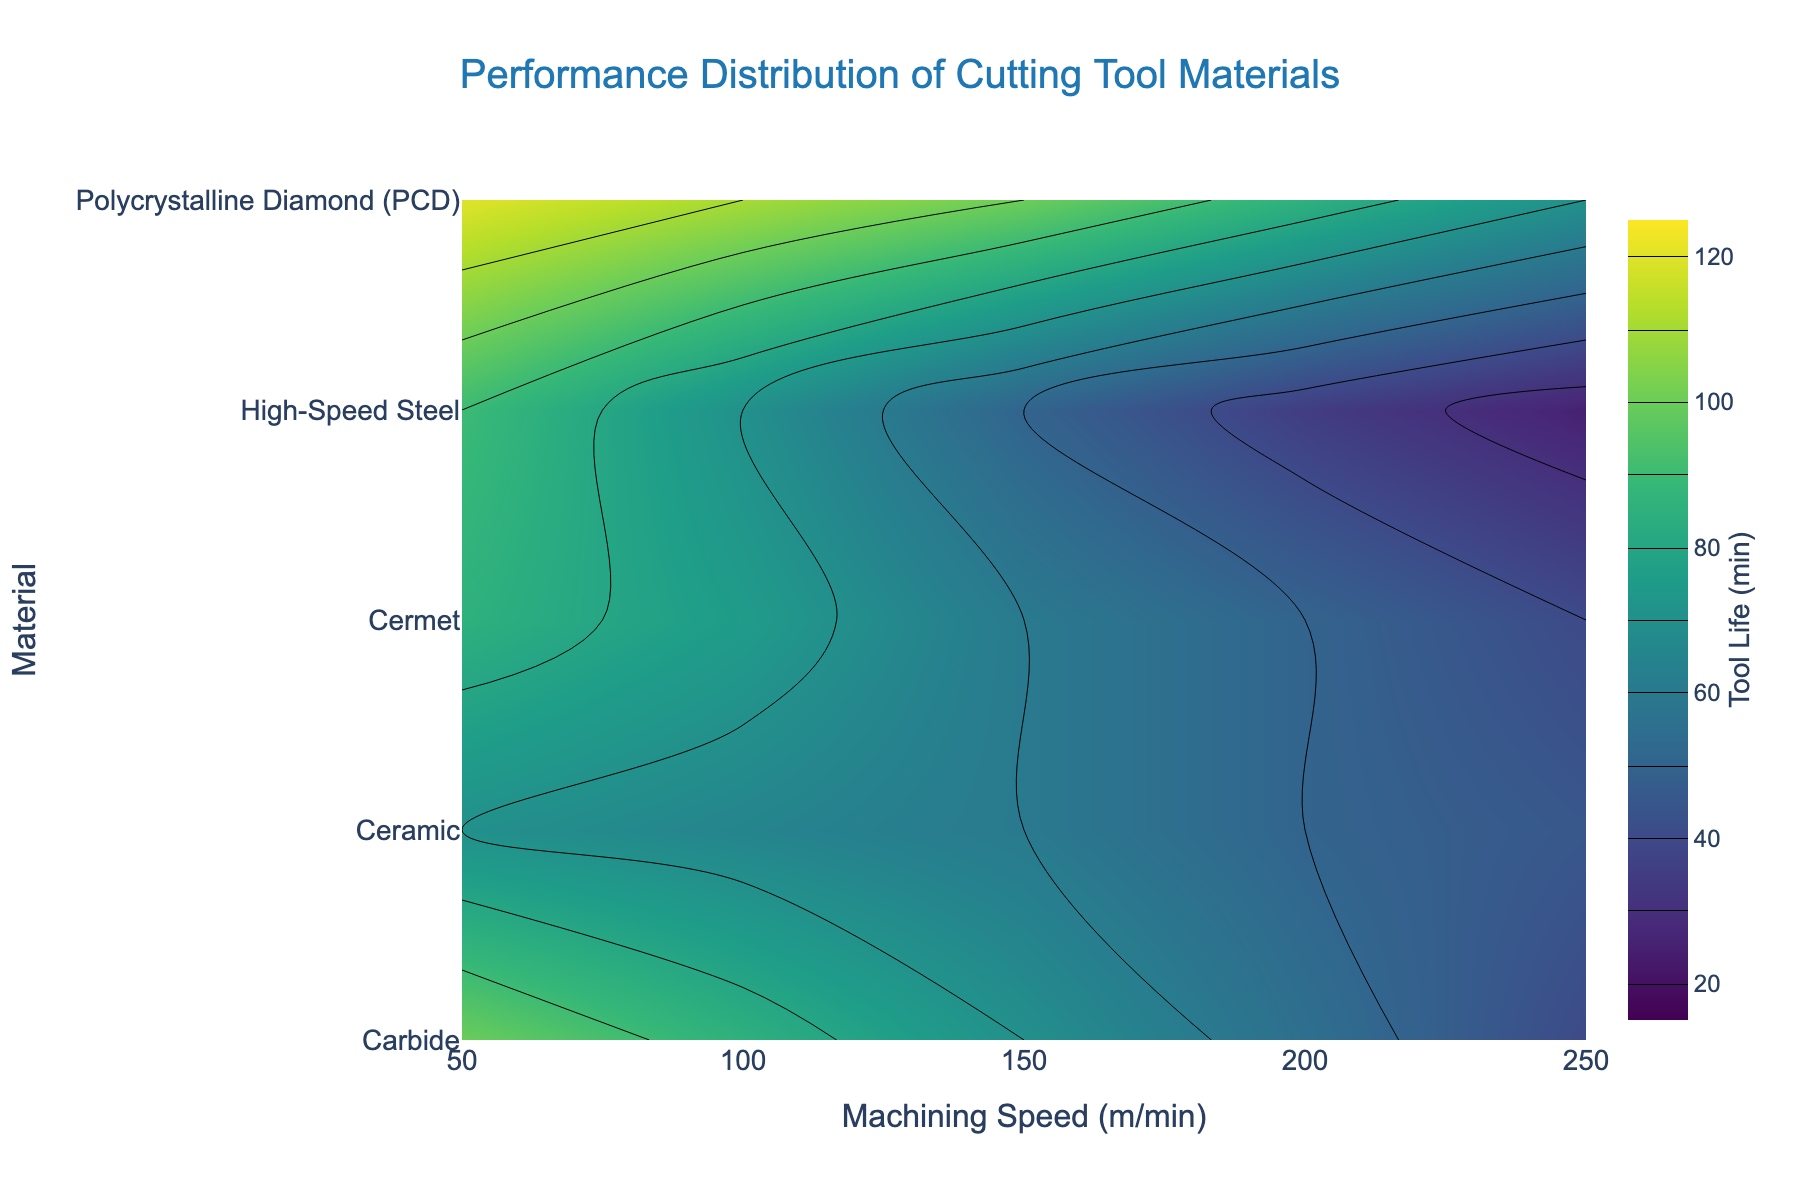What is the title of the plot? The title of the plot is usually displayed at the top of the figure. By referring to this area, one can read the given title.
Answer: Performance Distribution of Cutting Tool Materials What are the axes labels? The axes labels are found along the x-axis and y-axis, indicating what each axis represents. Here, the x-axis is labeled 'Machining Speed (m/min)', and the y-axis is labeled 'Material'.
Answer: Machining Speed (m/min) and Material Which material has the highest tool life at a speed of 50 m/min? By looking at the contour plot at the data point corresponding to 50 m/min on the x-axis, one can see the values for different materials. The highest tool life value at this point belongs to Polycrystalline Diamond (PCD).
Answer: Polycrystalline Diamond (PCD) What is the tool life of Carbide at a machining speed of 200 m/min? Locate the intersection point of Carbide and 200 m/min on the contour plot. The tooltip or color gradient at this point indicates the value. Here, it shows a tool life of 55 minutes.
Answer: 55 minutes Which material maintains relatively high tool life across all speeds? By examining the contour plot and the distribution of values for each material across various speeds, one can identify that Polycrystalline Diamond (PCD) consistently has higher tool life values across all speeds compared to other materials.
Answer: Polycrystalline Diamond (PCD) How does the performance of High-Speed Steel compare to Carbide at 100 m/min? Locate the data points for High-Speed Steel and Carbide at 100 m/min. Compare the tool life values – High-Speed Steel has a tool life of 70 minutes, whereas Carbide has a tool life of 85 minutes. Hence, Carbide outperforms High-Speed Steel at this speed.
Answer: Carbide is better What range of tool life values is indicated by the color gradient on the plot? The color gradient indicates the range of tool life values represented in the contour plot. By checking the color bar legend, the range can be found. Here, it starts at 20 minutes and ends at 120 minutes.
Answer: 20 to 120 minutes Which two materials have very similar performances at 250 m/min? By examining the plot at 250 m/min, it is clear that both Carbide and Cermet have similar tool life values, as they both show a tool life of around 40 minutes.
Answer: Carbide and Cermet Is there a material whose performance improves as machining speed increases? Generally, in machining processes, the tool life decreases with increasing speed. By examining the contour plot, no material shows an improvement in tool life with increased speeds. All materials show decreasing tool life as speed increases.
Answer: No material What is the average tool life of Ceramic across the range of speeds? To calculate the average, add up all tool life values for Ceramic and divide by the number of data points. The values are 70, 65, 60, 50, and 45 minutes. Sum is 70+65+60+50+45 = 290. The average is 290/5 = 58 minutes.
Answer: 58 minutes 